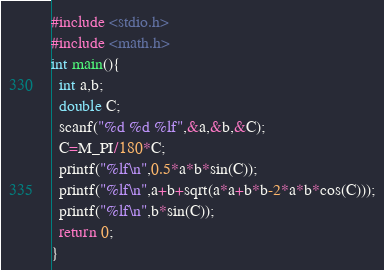Convert code to text. <code><loc_0><loc_0><loc_500><loc_500><_C_>#include <stdio.h>
#include <math.h>
int main(){
  int a,b;
  double C;
  scanf("%d %d %lf",&a,&b,&C);
  C=M_PI/180*C;
  printf("%lf\n",0.5*a*b*sin(C));
  printf("%lf\n",a+b+sqrt(a*a+b*b-2*a*b*cos(C)));
  printf("%lf\n",b*sin(C));
  return 0;
}
</code> 